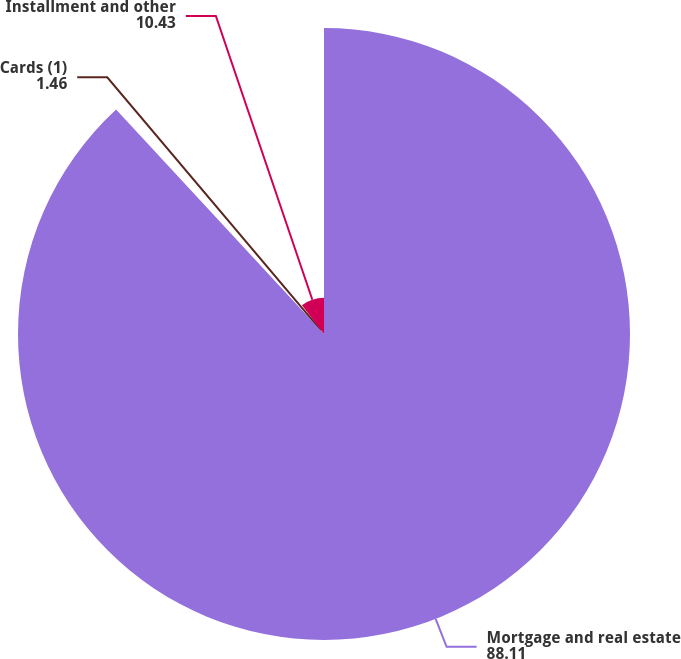<chart> <loc_0><loc_0><loc_500><loc_500><pie_chart><fcel>Mortgage and real estate<fcel>Cards (1)<fcel>Installment and other<nl><fcel>88.11%<fcel>1.46%<fcel>10.43%<nl></chart> 